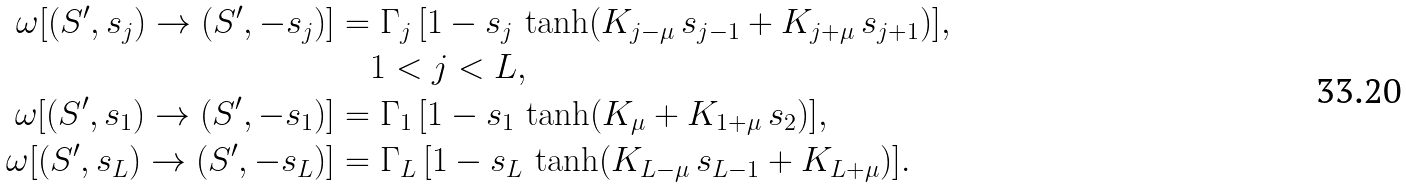<formula> <loc_0><loc_0><loc_500><loc_500>\omega [ ( S ^ { \prime } , s _ { j } ) \to ( S ^ { \prime } , - s _ { j } ) ] & = \Gamma _ { j } \, [ 1 - s _ { j } \, \tanh ( K _ { j - \mu } \, s _ { j - 1 } + K _ { j + \mu } \, s _ { j + 1 } ) ] , \\ & \quad 1 < j < L , \\ \omega [ ( S ^ { \prime } , s _ { 1 } ) \to ( S ^ { \prime } , - s _ { 1 } ) ] & = \Gamma _ { 1 } \, [ 1 - s _ { 1 } \, \tanh ( K _ { \mu } + K _ { 1 + \mu } \, s _ { 2 } ) ] , \\ \omega [ ( S ^ { \prime } , s _ { L } ) \to ( S ^ { \prime } , - s _ { L } ) ] & = \Gamma _ { L } \, [ 1 - s _ { L } \, \tanh ( K _ { L - \mu } \, s _ { L - 1 } + K _ { L + \mu } ) ] .</formula> 